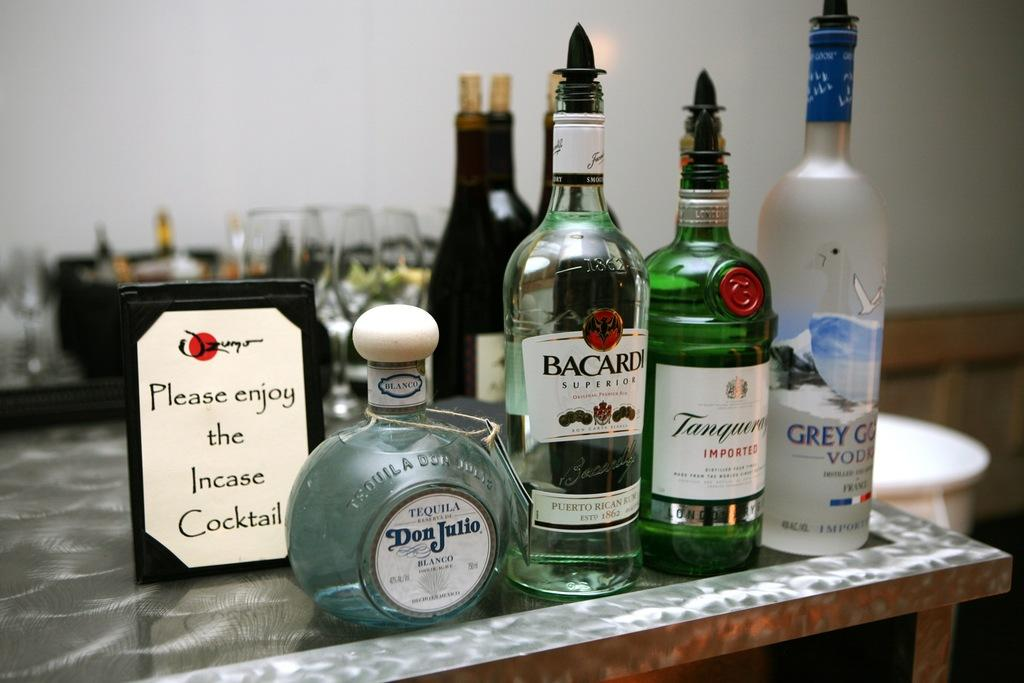<image>
Describe the image concisely. Many bottles of alcohol on a table with a sign that says "Please enjoy the incase cocktail". 